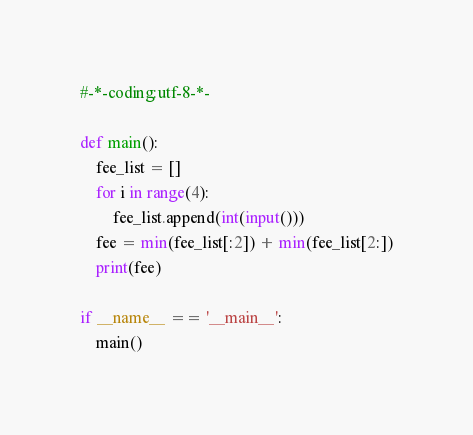<code> <loc_0><loc_0><loc_500><loc_500><_Python_>#-*-coding:utf-8-*-

def main():
    fee_list = []
    for i in range(4):
        fee_list.append(int(input()))
    fee = min(fee_list[:2]) + min(fee_list[2:])
    print(fee)

if __name__ == '__main__':
    main()</code> 